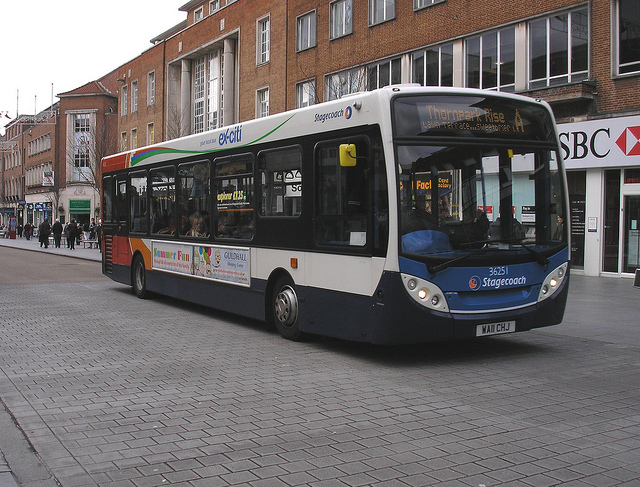<image>Why is the road made of brick? It is unknown why the road is made of brick. It could be for various reasons such as style, decoration, or functionality. Why is the road made of brick? It is not clear why the road is made of brick. It can be for easy placement, decoration, or to adjust to traffic. 